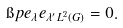<formula> <loc_0><loc_0><loc_500><loc_500>\i p { e _ { \lambda } } { e _ { \lambda ^ { \prime } } } _ { L ^ { 2 } ( G ) } = 0 .</formula> 